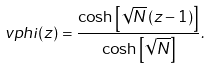Convert formula to latex. <formula><loc_0><loc_0><loc_500><loc_500>\ v p h i ( z ) = \frac { \cosh \left [ \sqrt { N } \, ( z - 1 ) \right ] } { \cosh \left [ \sqrt { N } \right ] } .</formula> 